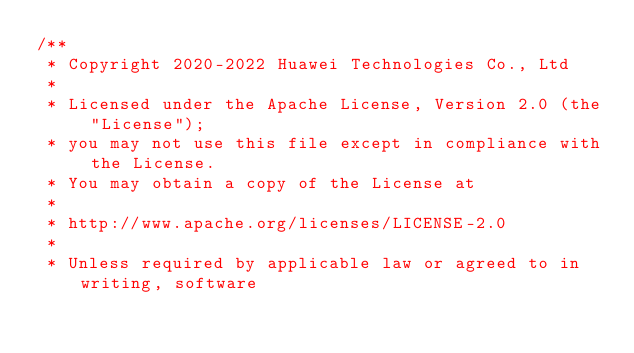Convert code to text. <code><loc_0><loc_0><loc_500><loc_500><_C_>/**
 * Copyright 2020-2022 Huawei Technologies Co., Ltd
 *
 * Licensed under the Apache License, Version 2.0 (the "License");
 * you may not use this file except in compliance with the License.
 * You may obtain a copy of the License at
 *
 * http://www.apache.org/licenses/LICENSE-2.0
 *
 * Unless required by applicable law or agreed to in writing, software</code> 